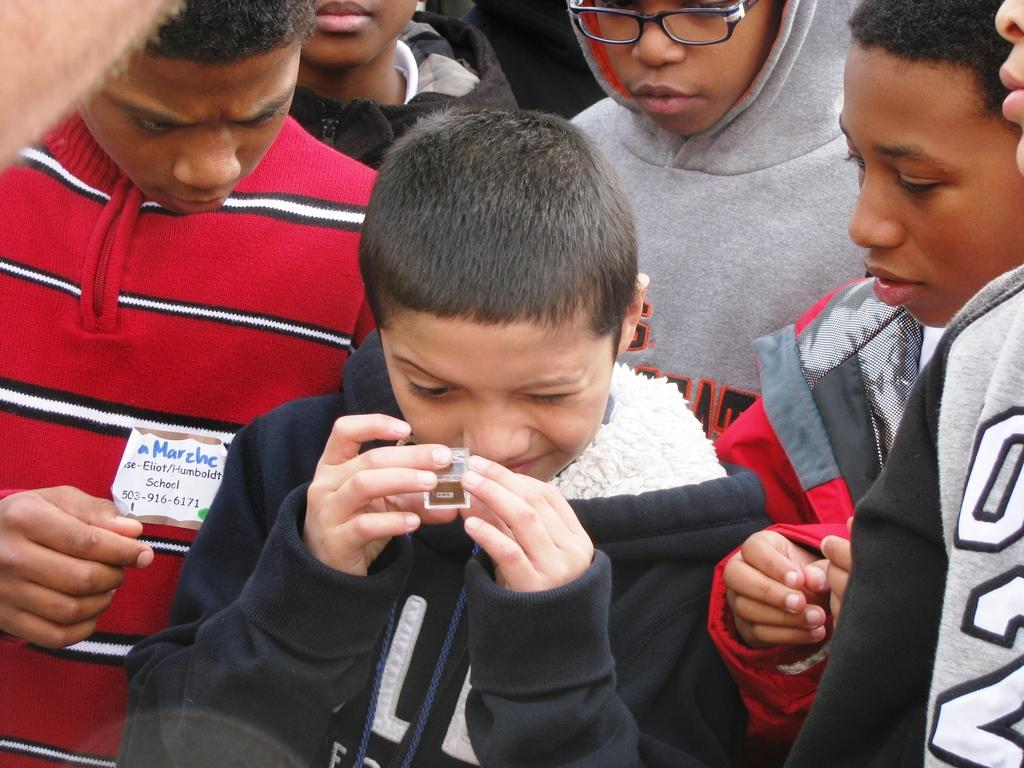How many people are in the image? There are many people in the image. Can you describe the boy standing in the front of the image? The boy in the front is wearing a black jacket. Where is the boy wearing the red jacket located in the image? The boy wearing the red jacket is on the left side of the image. What type of waste is being disposed of by the people in the image? There is no mention of waste disposal in the image; it primarily features people standing in various positions. 